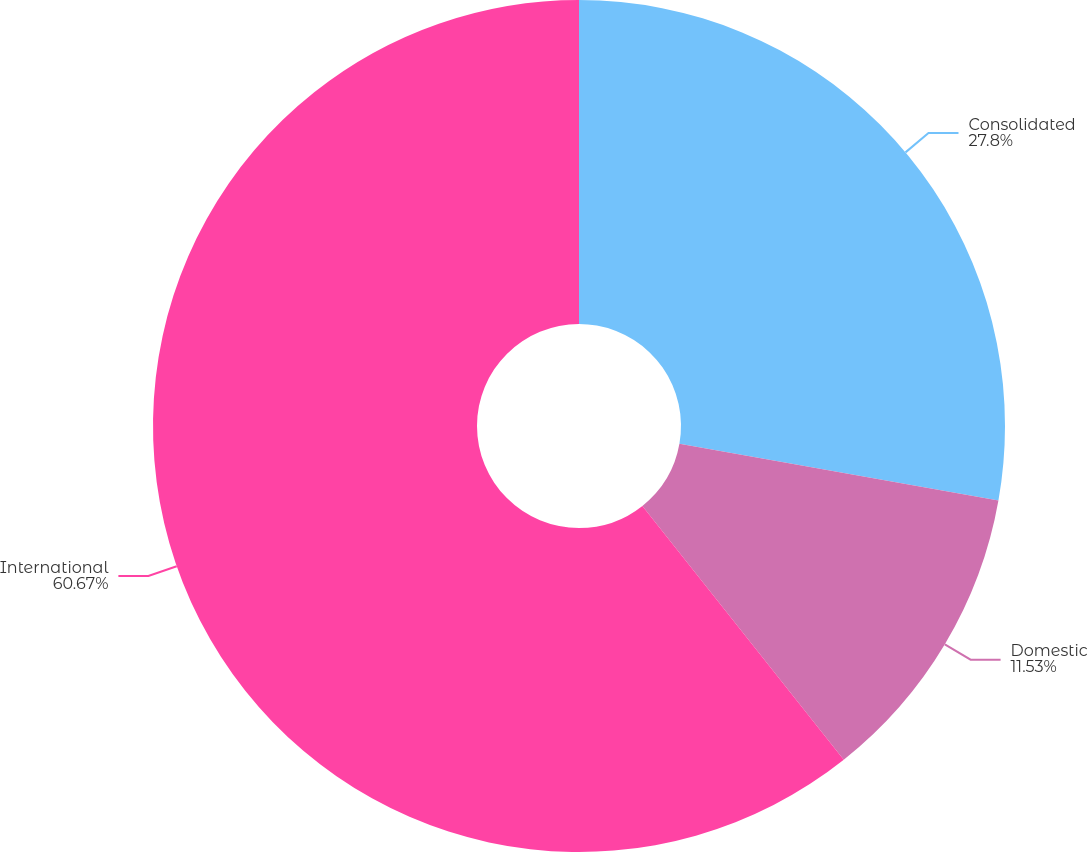Convert chart to OTSL. <chart><loc_0><loc_0><loc_500><loc_500><pie_chart><fcel>Consolidated<fcel>Domestic<fcel>International<nl><fcel>27.8%<fcel>11.53%<fcel>60.68%<nl></chart> 